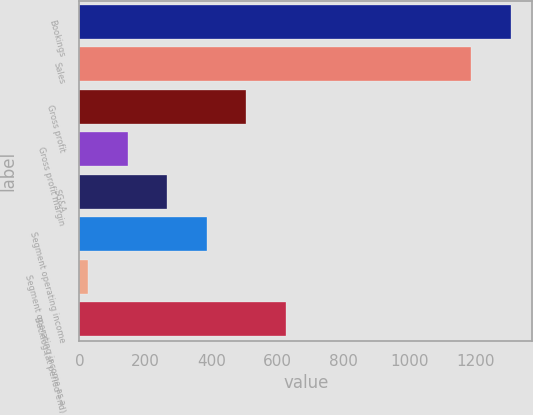Convert chart to OTSL. <chart><loc_0><loc_0><loc_500><loc_500><bar_chart><fcel>Bookings<fcel>Sales<fcel>Gross profit<fcel>Gross profit margin<fcel>SG&A<fcel>Segment operating income<fcel>Segment operating income as a<fcel>Backlog (at period end)<nl><fcel>1307.95<fcel>1188.1<fcel>506.6<fcel>147.05<fcel>266.9<fcel>386.75<fcel>27.2<fcel>626.45<nl></chart> 